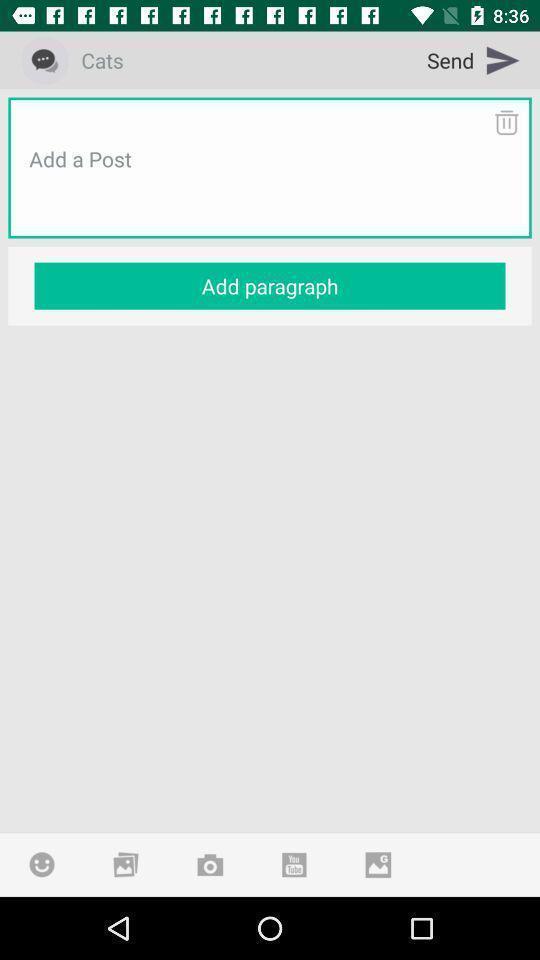Describe the key features of this screenshot. Screen displaying add a post option an application. 